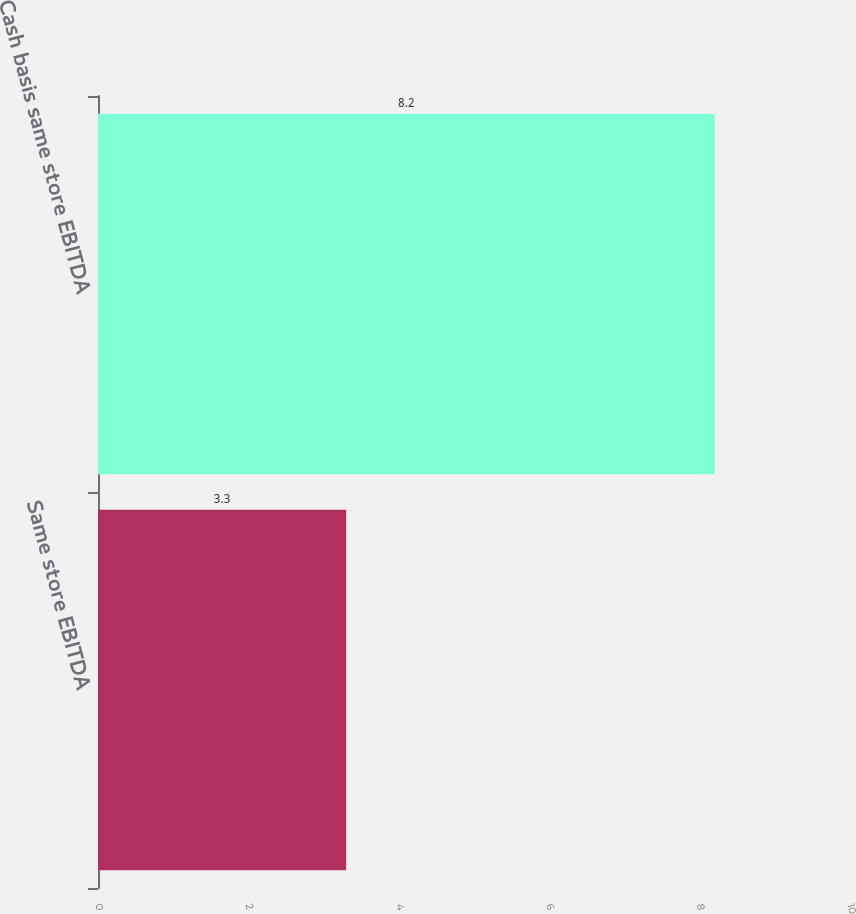<chart> <loc_0><loc_0><loc_500><loc_500><bar_chart><fcel>Same store EBITDA<fcel>Cash basis same store EBITDA<nl><fcel>3.3<fcel>8.2<nl></chart> 